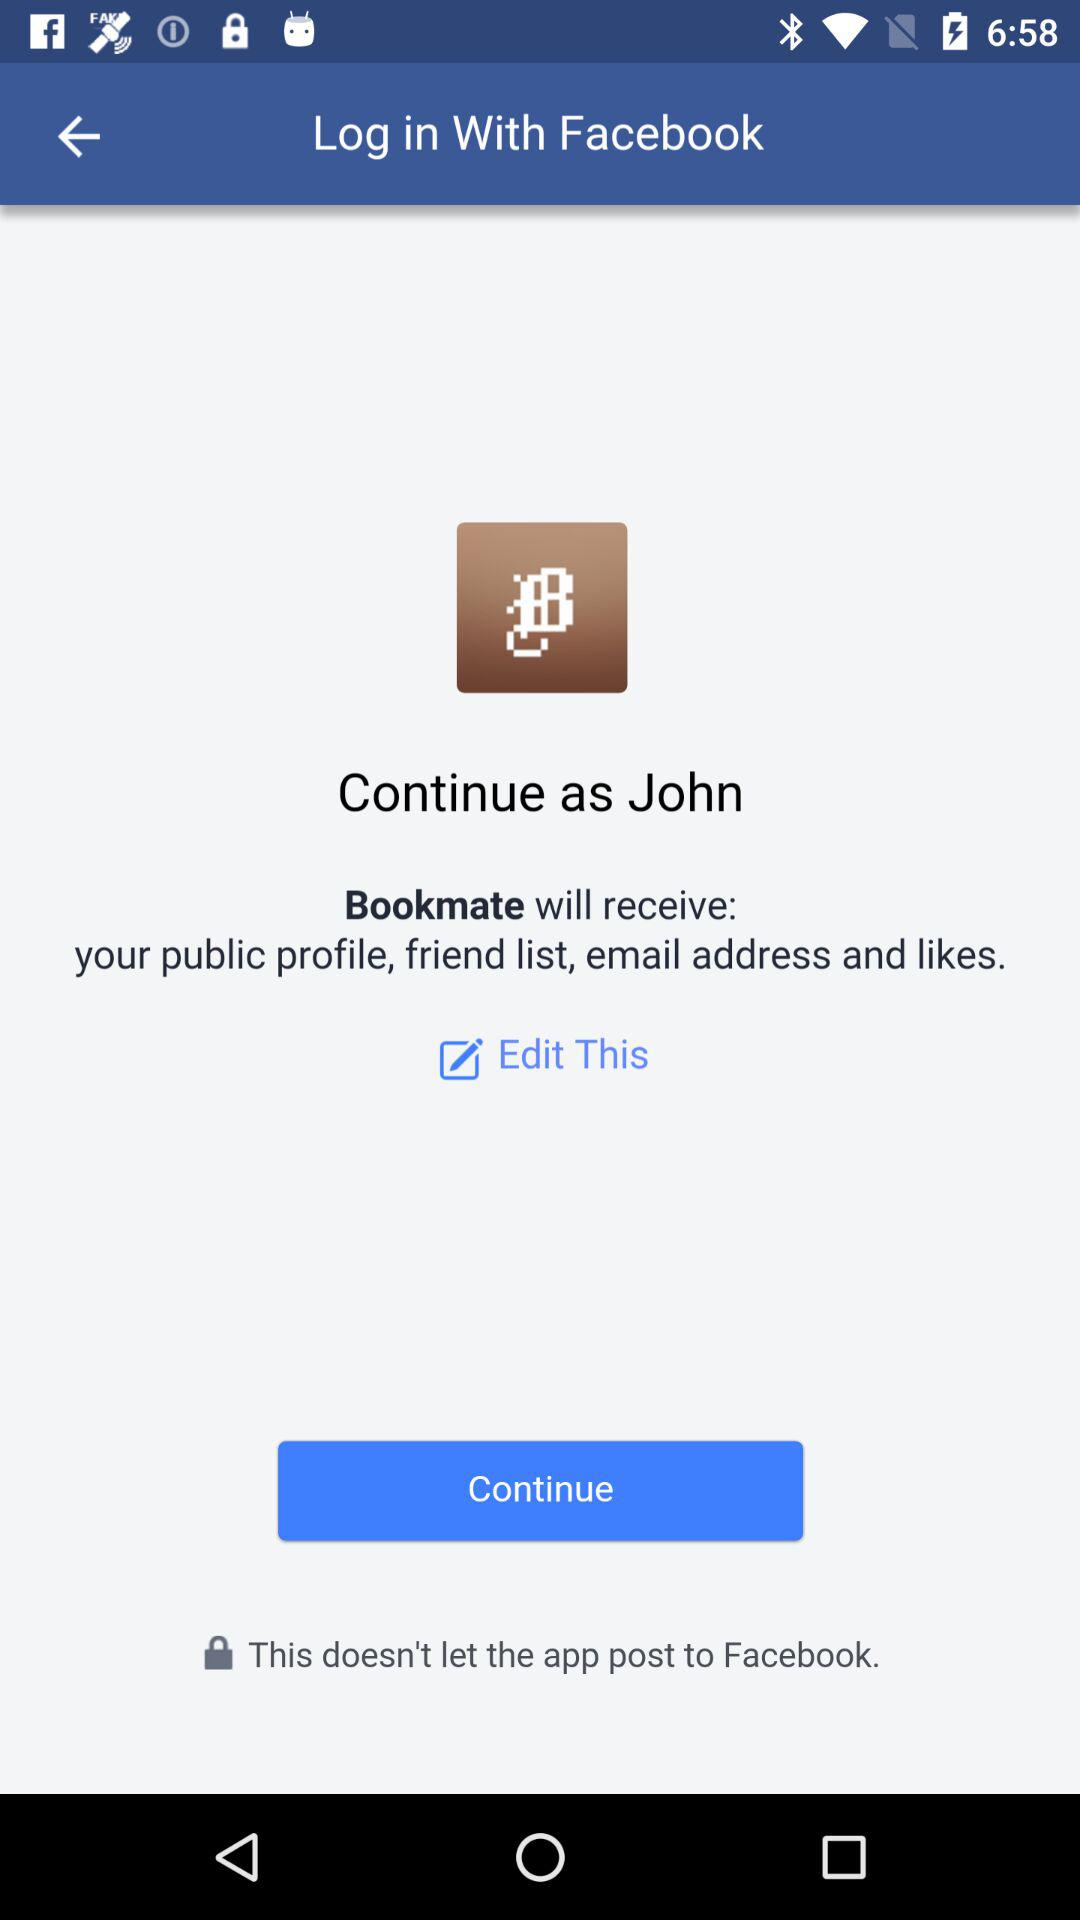What application will receive a public profile and email address? The application is "Bookmate". 